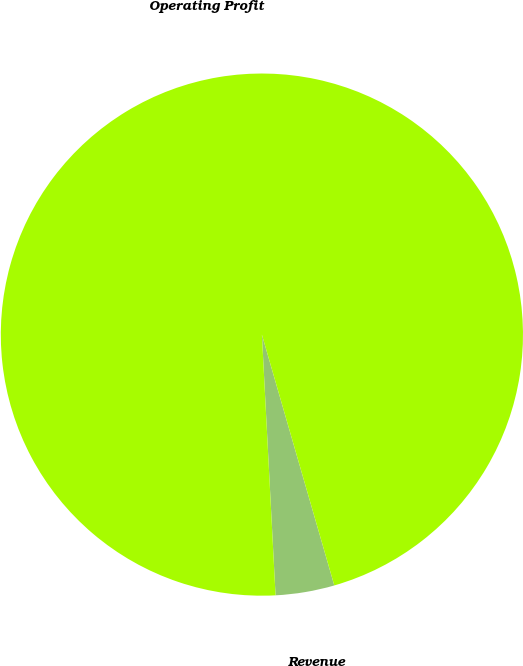Convert chart to OTSL. <chart><loc_0><loc_0><loc_500><loc_500><pie_chart><fcel>Revenue<fcel>Operating Profit<nl><fcel>3.64%<fcel>96.36%<nl></chart> 